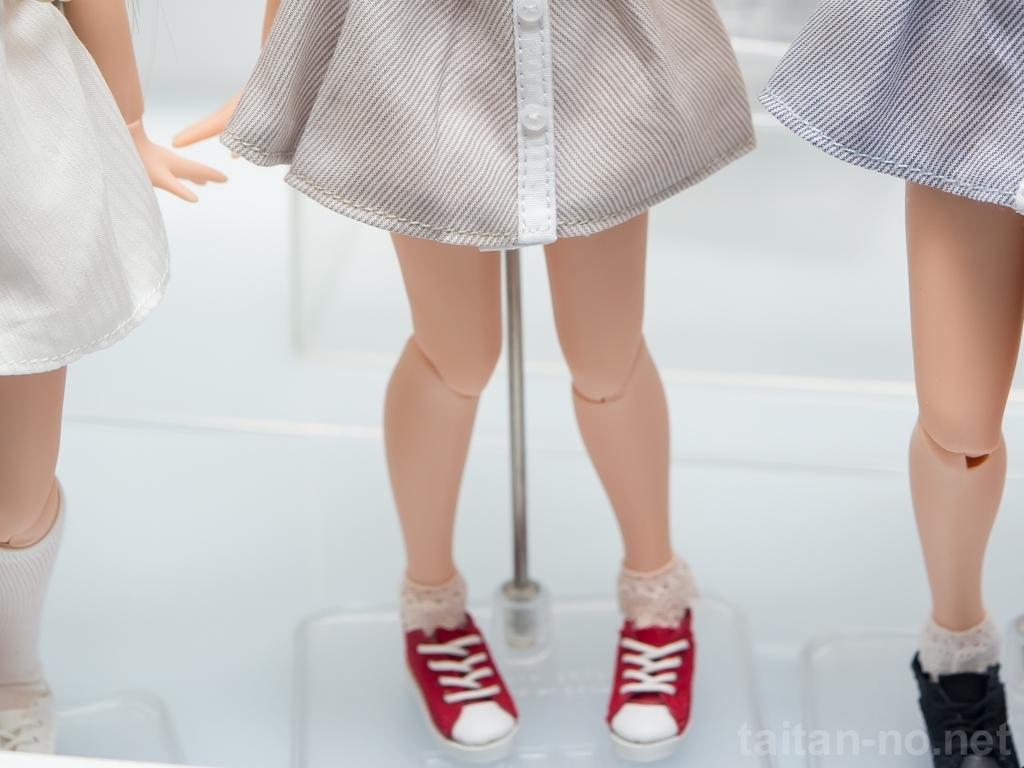How does the choice of cropping affect the perception of these figures? The cropping, which displays only the lower halves of the figures, creates an air of mystery and focuses the viewer's attention on the clothing details and overall styling from the waist down. Without the distraction of facial expressions or upper body language, we're drawn to interpret the fashion narrative being presented – the way the textures, colors, and even the choice of socks and shoes interact to make a bold statement. This type of framing is particularly compelling in today's fashion industry, which often emphasizes individual elements of an outfit. 